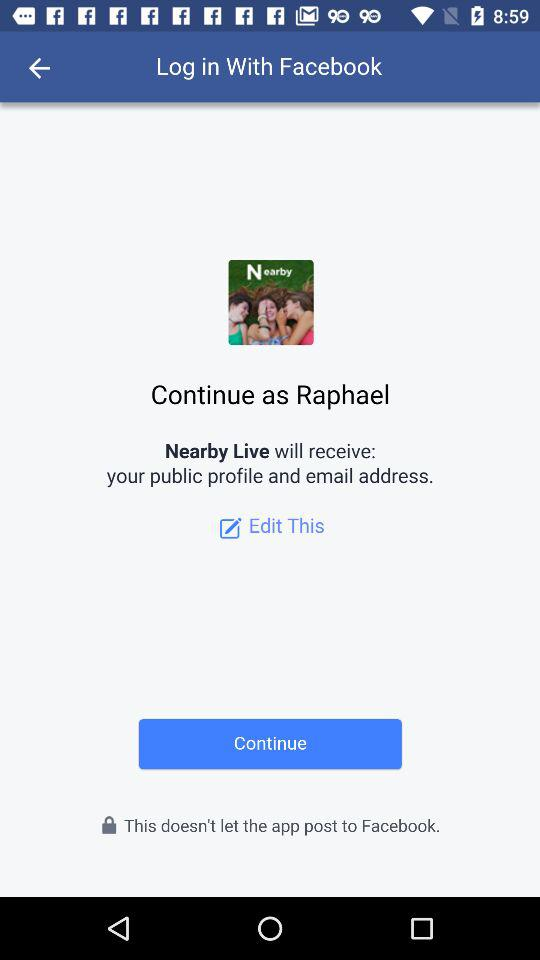What is the name of the user? The name of the user is Raphael. 